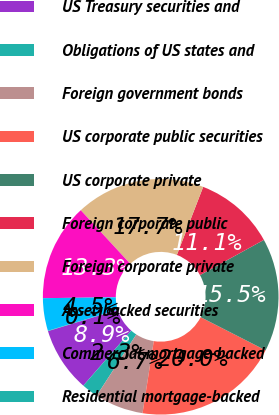<chart> <loc_0><loc_0><loc_500><loc_500><pie_chart><fcel>US Treasury securities and<fcel>Obligations of US states and<fcel>Foreign government bonds<fcel>US corporate public securities<fcel>US corporate private<fcel>Foreign corporate public<fcel>Foreign corporate private<fcel>Asset-backed securities<fcel>Commercial mortgage-backed<fcel>Residential mortgage-backed<nl><fcel>8.89%<fcel>2.26%<fcel>6.68%<fcel>19.95%<fcel>15.53%<fcel>11.11%<fcel>17.74%<fcel>13.32%<fcel>4.47%<fcel>0.05%<nl></chart> 